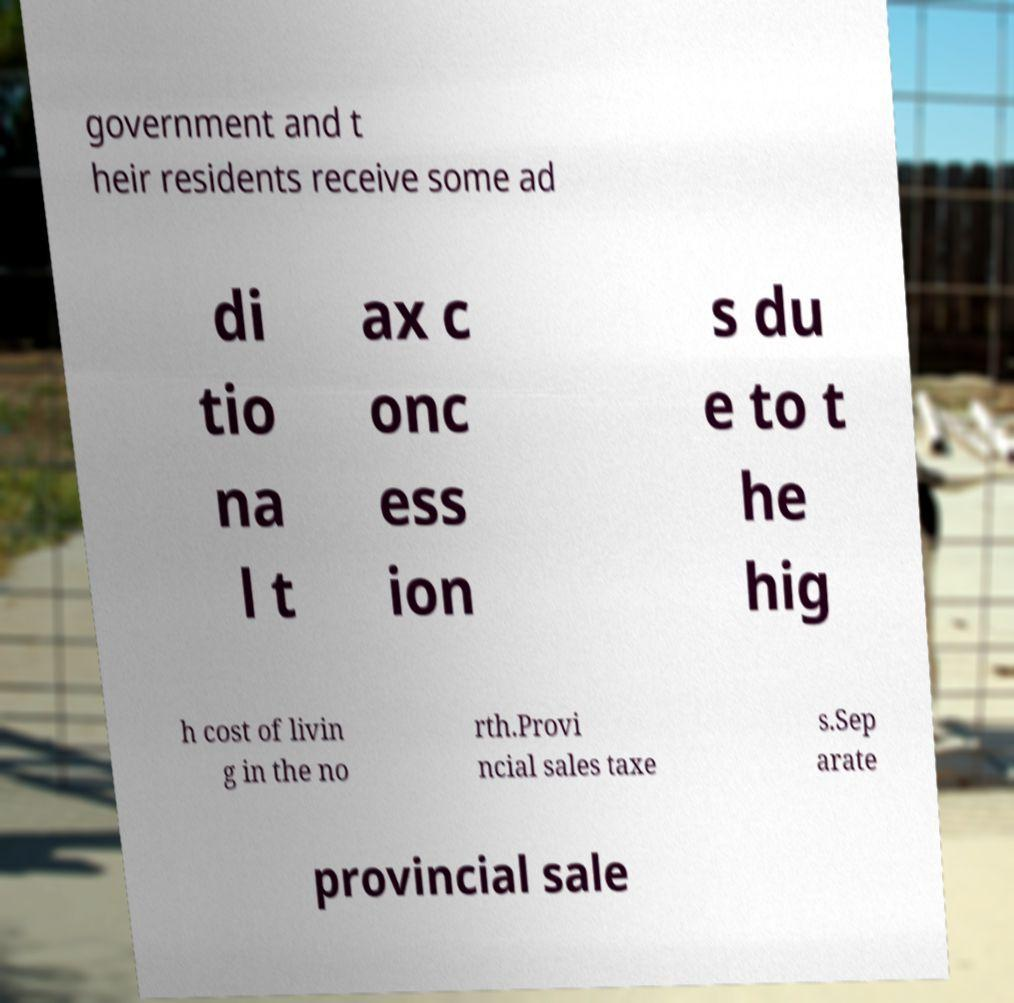What messages or text are displayed in this image? I need them in a readable, typed format. government and t heir residents receive some ad di tio na l t ax c onc ess ion s du e to t he hig h cost of livin g in the no rth.Provi ncial sales taxe s.Sep arate provincial sale 